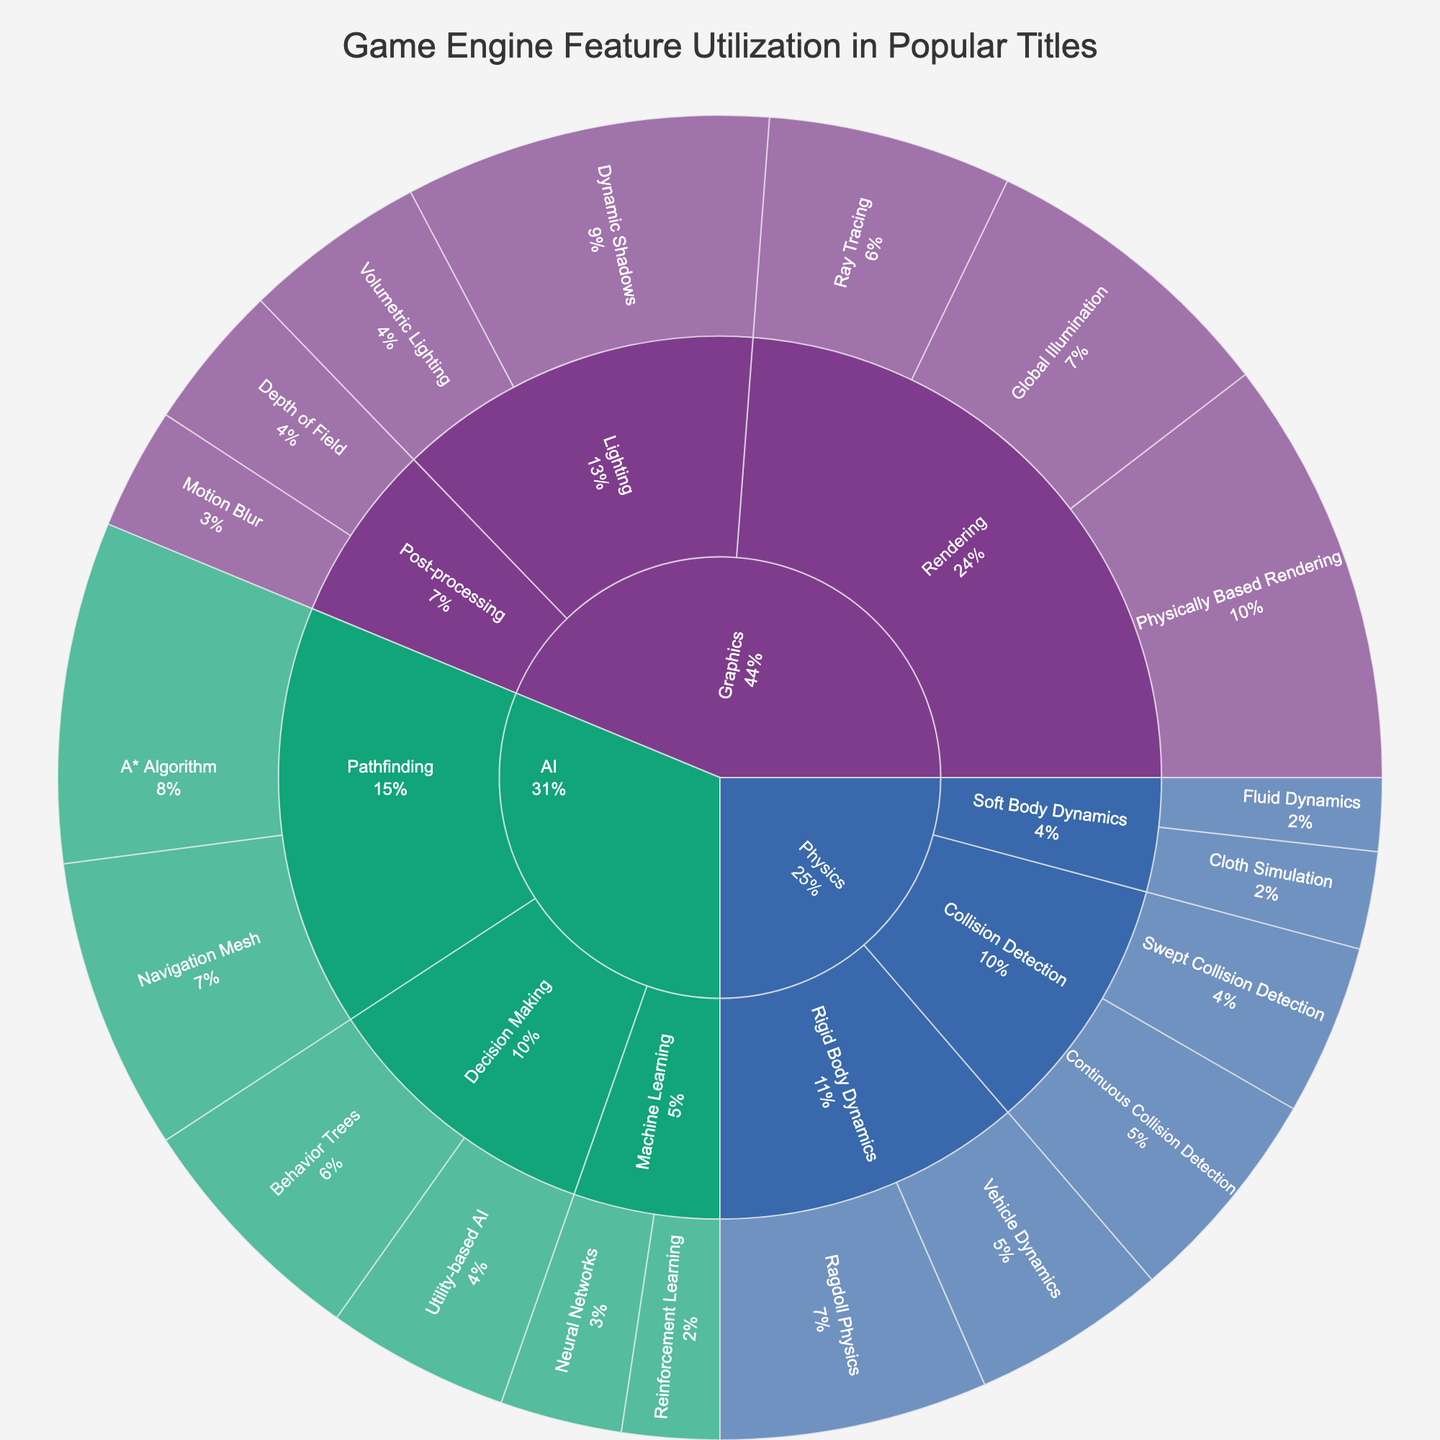Who uses Ray Tracing more: Graphics or AI? To answer this, we need to compare the value of Ray Tracing under Graphics with the total value under AI. Ray Tracing has a value of 20 under Graphics. AI does not have a Ray Tracing feature, so its value would be 0 for comparison. Therefore, Graphics uses Ray Tracing more.
Answer: Graphics What's the total value for all soft body dynamics features? To find the total value, sum up the values for Cloth Simulation and Fluid Dynamics under Soft Body Dynamics. Cloth Simulation has a value of 8 and Fluid Dynamics has 6. Adding these gives 8 + 6 = 14.
Answer: 14 Which subcategory within Graphics has the least overall utilization? Sum the values for each subcategory and compare. Rendering: 35 + 20 + 25 = 80, Lighting: 30 + 15 = 45, Post-processing: 10 + 12 = 22. Post-processing has the lowest value at 22.
Answer: Post-processing What is the most utilized feature in AI? Look at the values for each feature under AI. A* Algorithm has 28, Navigation Mesh has 24, Behavior Trees has 20, Utility-based AI has 15, Neural Networks has 10, and Reinforcement Learning has 8. The highest value is 28 for A* Algorithm.
Answer: A* Algorithm How much less utilized is Fluid Dynamics compared to Global Illumination? Determine the values for Fluid Dynamics and Global Illumination, which are 6 and 25 respectively. Subtract Fluid Dynamics' value from Global Illumination's: 25 - 6 = 19. Fluid Dynamics is 19 less utilized.
Answer: 19 What percentage of the total game engine features does Graphics account for? Sum the total values for all categories. Graphics: 35 + 20 + 25 + 30 + 15 + 10 + 12 = 147, Physics: 18 + 14 + 22 + 16 + 8 + 6 = 84, AI: 28 + 24 + 20 + 15 + 10 + 8 = 105. Total = 147 + 84 + 105 = 336. The percentage for Graphics is (147 / 336) * 100 ≈ 43.8%.
Answer: ~43.8% Which category has the highest total utilization in the game engine features? Sum the total values for each category. Graphics: 147, Physics: 84, AI: 105. Graphics has the highest total utilization at 147.
Answer: Graphics 